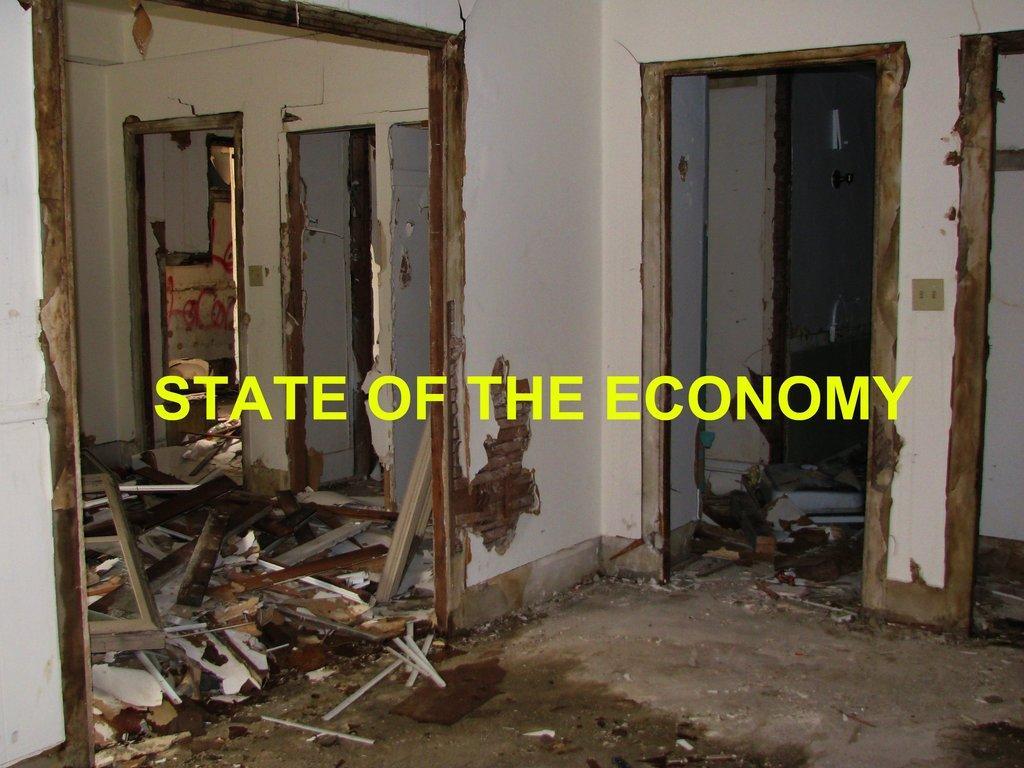Please provide a concise description of this image. This is the inside view of a building. Here we can see wood and this is wall. 